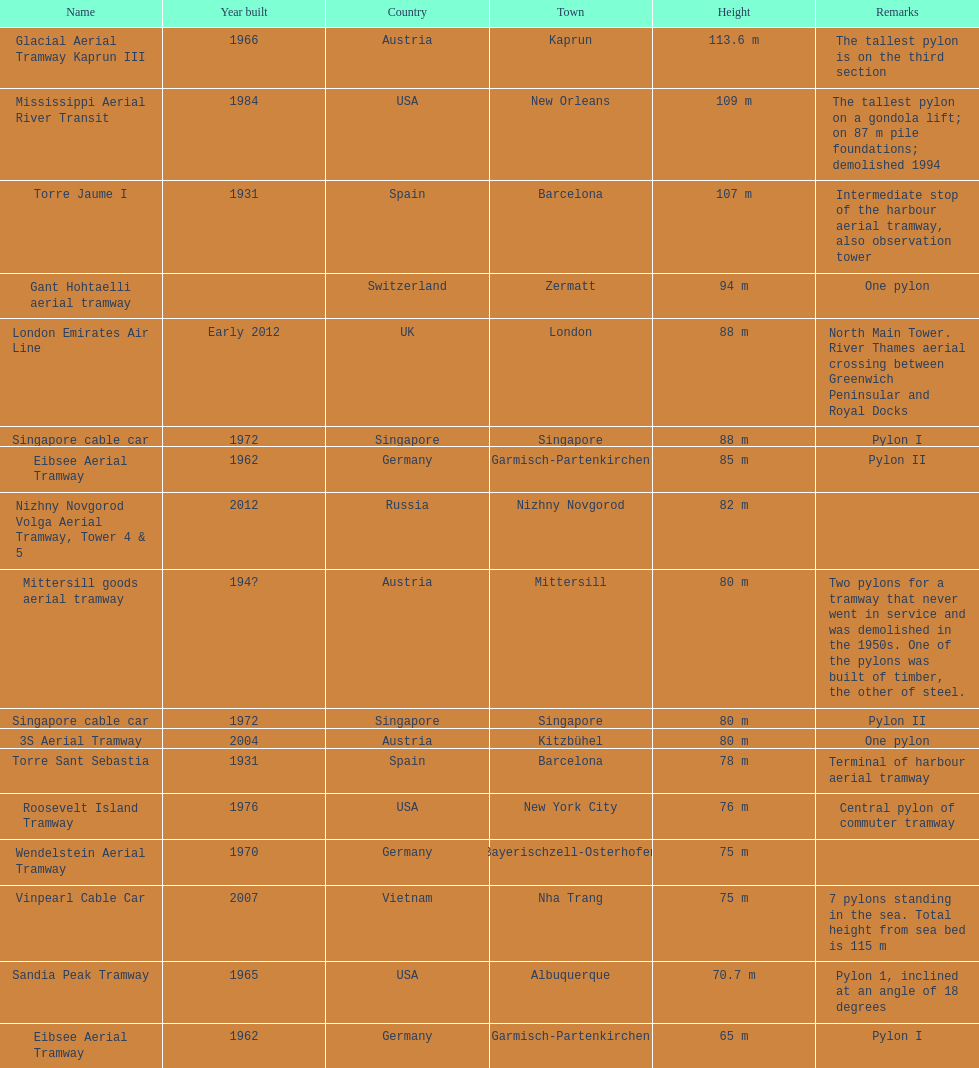What is the aggregate amount of the highest pylons in austria? 3. 